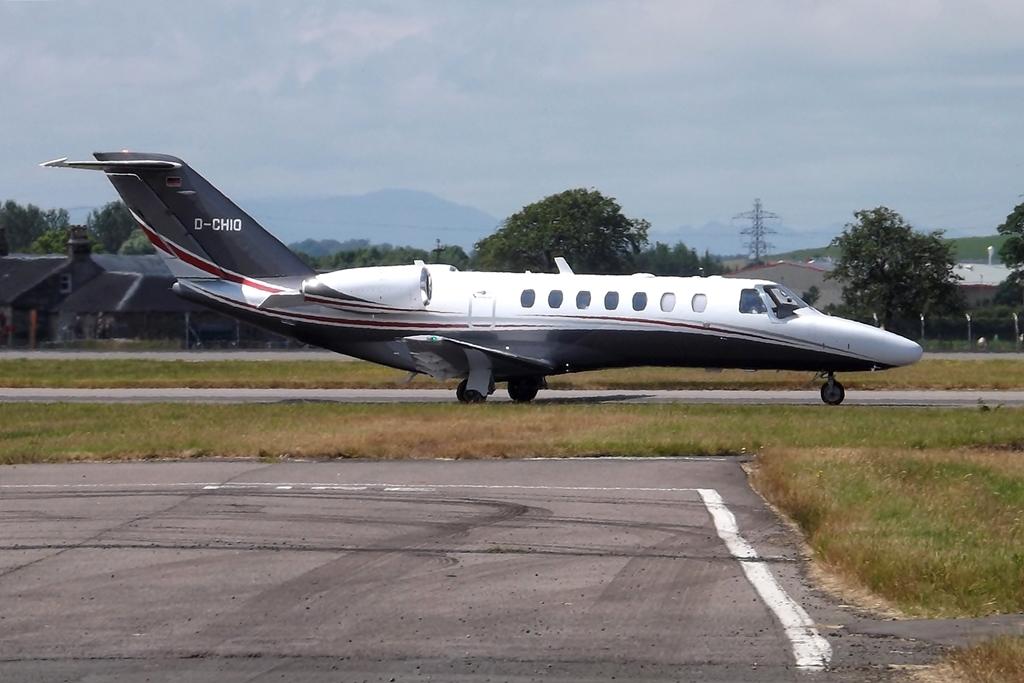What is the id number written on the rear of the plane?
Give a very brief answer. D-chio. 